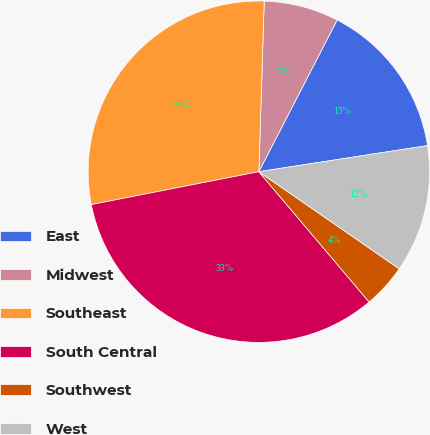Convert chart. <chart><loc_0><loc_0><loc_500><loc_500><pie_chart><fcel>East<fcel>Midwest<fcel>Southeast<fcel>South Central<fcel>Southwest<fcel>West<nl><fcel>14.97%<fcel>7.08%<fcel>28.59%<fcel>33.09%<fcel>4.19%<fcel>12.08%<nl></chart> 